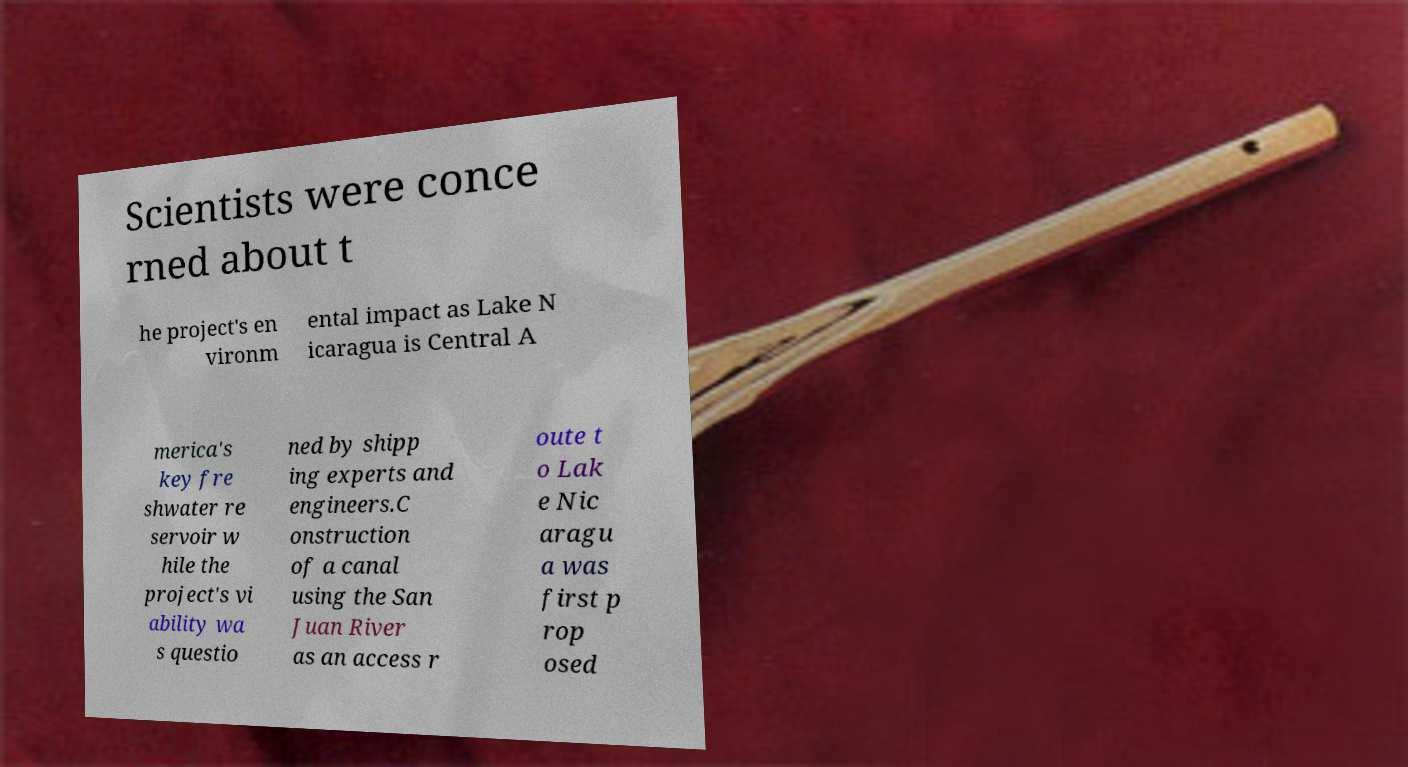What messages or text are displayed in this image? I need them in a readable, typed format. Scientists were conce rned about t he project's en vironm ental impact as Lake N icaragua is Central A merica's key fre shwater re servoir w hile the project's vi ability wa s questio ned by shipp ing experts and engineers.C onstruction of a canal using the San Juan River as an access r oute t o Lak e Nic aragu a was first p rop osed 